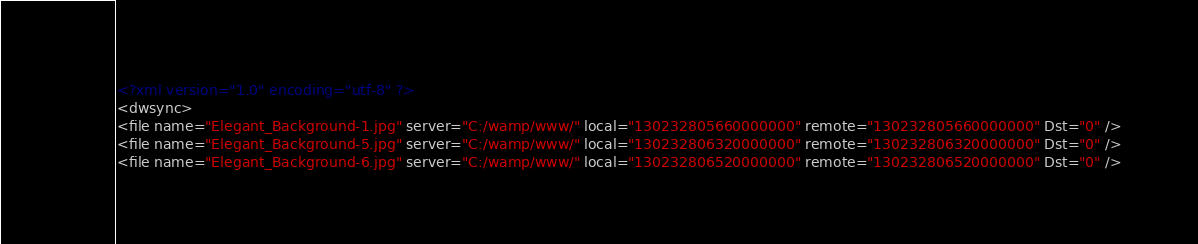Convert code to text. <code><loc_0><loc_0><loc_500><loc_500><_XML_><?xml version="1.0" encoding="utf-8" ?>
<dwsync>
<file name="Elegant_Background-1.jpg" server="C:/wamp/www/" local="130232805660000000" remote="130232805660000000" Dst="0" />
<file name="Elegant_Background-5.jpg" server="C:/wamp/www/" local="130232806320000000" remote="130232806320000000" Dst="0" />
<file name="Elegant_Background-6.jpg" server="C:/wamp/www/" local="130232806520000000" remote="130232806520000000" Dst="0" /></code> 